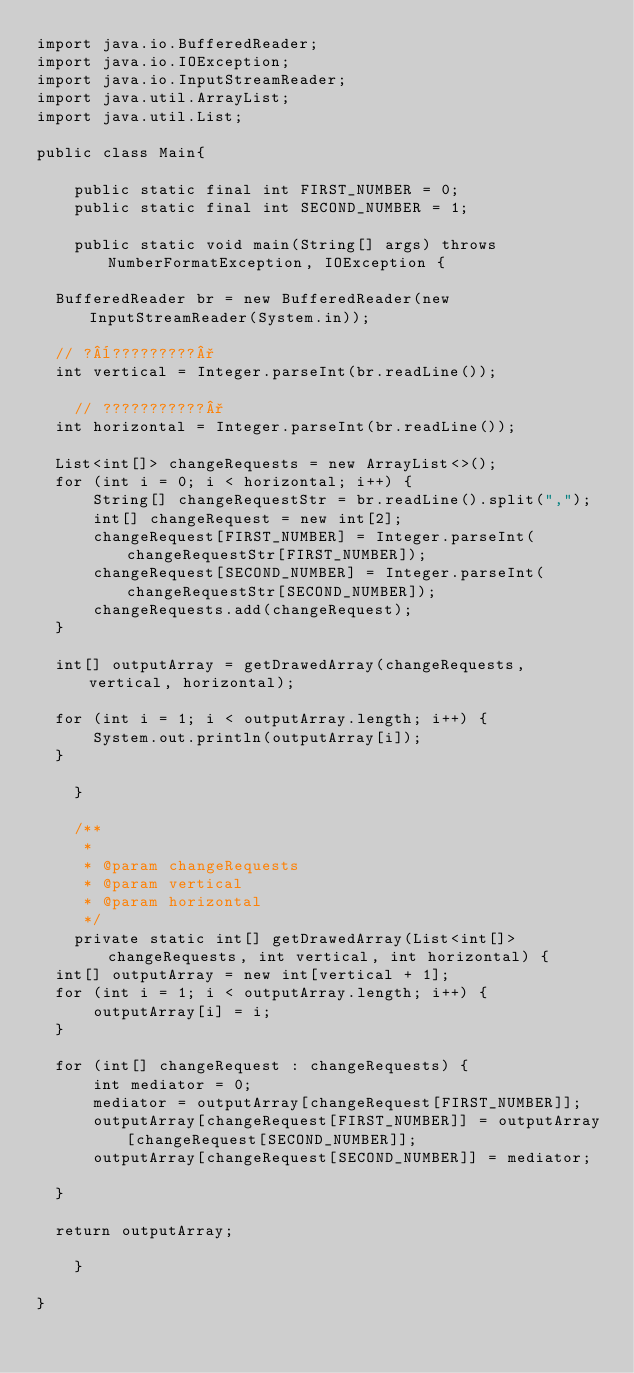<code> <loc_0><loc_0><loc_500><loc_500><_Java_>import java.io.BufferedReader;
import java.io.IOException;
import java.io.InputStreamReader;
import java.util.ArrayList;
import java.util.List;

public class Main{

    public static final int FIRST_NUMBER = 0;
    public static final int SECOND_NUMBER = 1;

    public static void main(String[] args) throws NumberFormatException, IOException {

	BufferedReader br = new BufferedReader(new InputStreamReader(System.in));

	// ?¨?????????°
	int vertical = Integer.parseInt(br.readLine());

    // ???????????°	
	int horizontal = Integer.parseInt(br.readLine());

	List<int[]> changeRequests = new ArrayList<>();
	for (int i = 0; i < horizontal; i++) {
	    String[] changeRequestStr = br.readLine().split(",");
	    int[] changeRequest = new int[2];
	    changeRequest[FIRST_NUMBER] = Integer.parseInt(changeRequestStr[FIRST_NUMBER]);
	    changeRequest[SECOND_NUMBER] = Integer.parseInt(changeRequestStr[SECOND_NUMBER]);
	    changeRequests.add(changeRequest);
	}

	int[] outputArray = getDrawedArray(changeRequests, vertical, horizontal);

	for (int i = 1; i < outputArray.length; i++) {
	    System.out.println(outputArray[i]);
	}

    }

    /**
     *
     * @param changeRequests
     * @param vertical
     * @param horizontal
     */
    private static int[] getDrawedArray(List<int[]> changeRequests, int vertical, int horizontal) {
	int[] outputArray = new int[vertical + 1];
	for (int i = 1; i < outputArray.length; i++) {
	    outputArray[i] = i;
	}

	for (int[] changeRequest : changeRequests) {
	    int mediator = 0;
	    mediator = outputArray[changeRequest[FIRST_NUMBER]];
	    outputArray[changeRequest[FIRST_NUMBER]] = outputArray[changeRequest[SECOND_NUMBER]];
	    outputArray[changeRequest[SECOND_NUMBER]] = mediator;

	}

	return outputArray;

    }

}</code> 